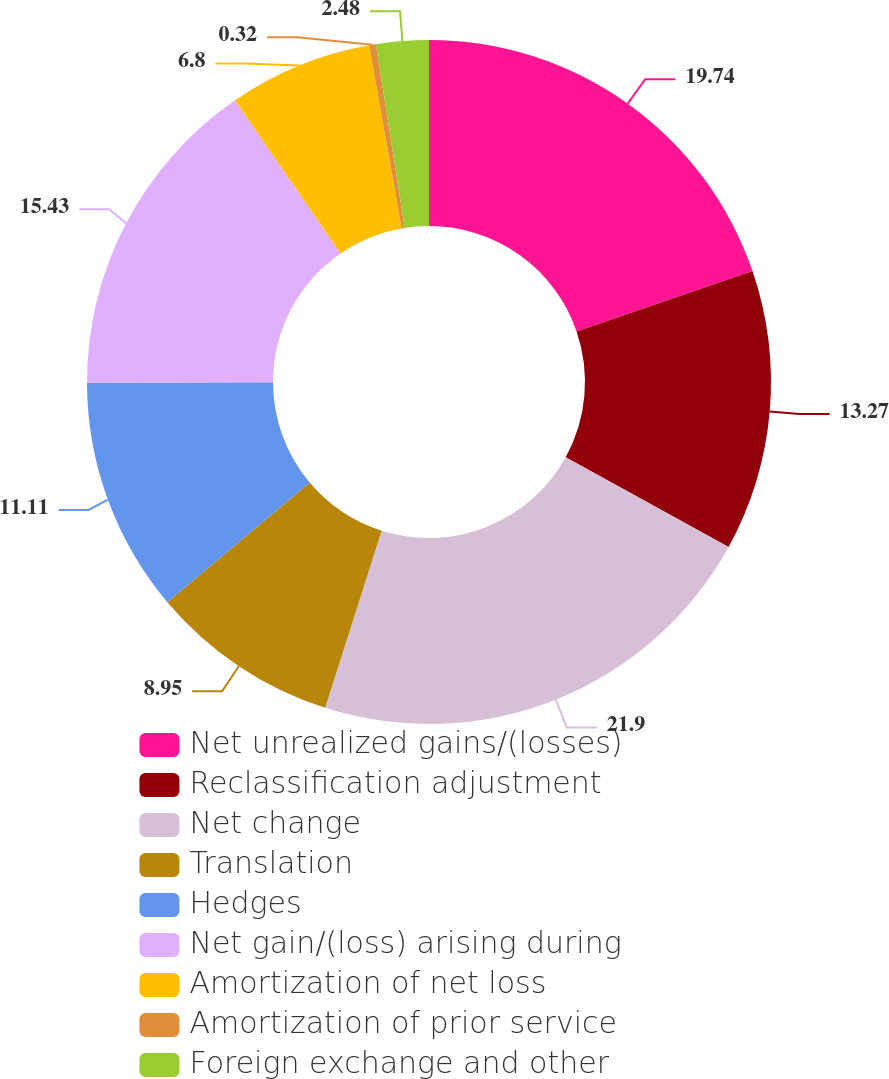<chart> <loc_0><loc_0><loc_500><loc_500><pie_chart><fcel>Net unrealized gains/(losses)<fcel>Reclassification adjustment<fcel>Net change<fcel>Translation<fcel>Hedges<fcel>Net gain/(loss) arising during<fcel>Amortization of net loss<fcel>Amortization of prior service<fcel>Foreign exchange and other<nl><fcel>19.74%<fcel>13.27%<fcel>21.9%<fcel>8.95%<fcel>11.11%<fcel>15.43%<fcel>6.8%<fcel>0.32%<fcel>2.48%<nl></chart> 